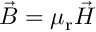<formula> <loc_0><loc_0><loc_500><loc_500>{ \vec { B } } = \mu _ { r } { \vec { H } }</formula> 